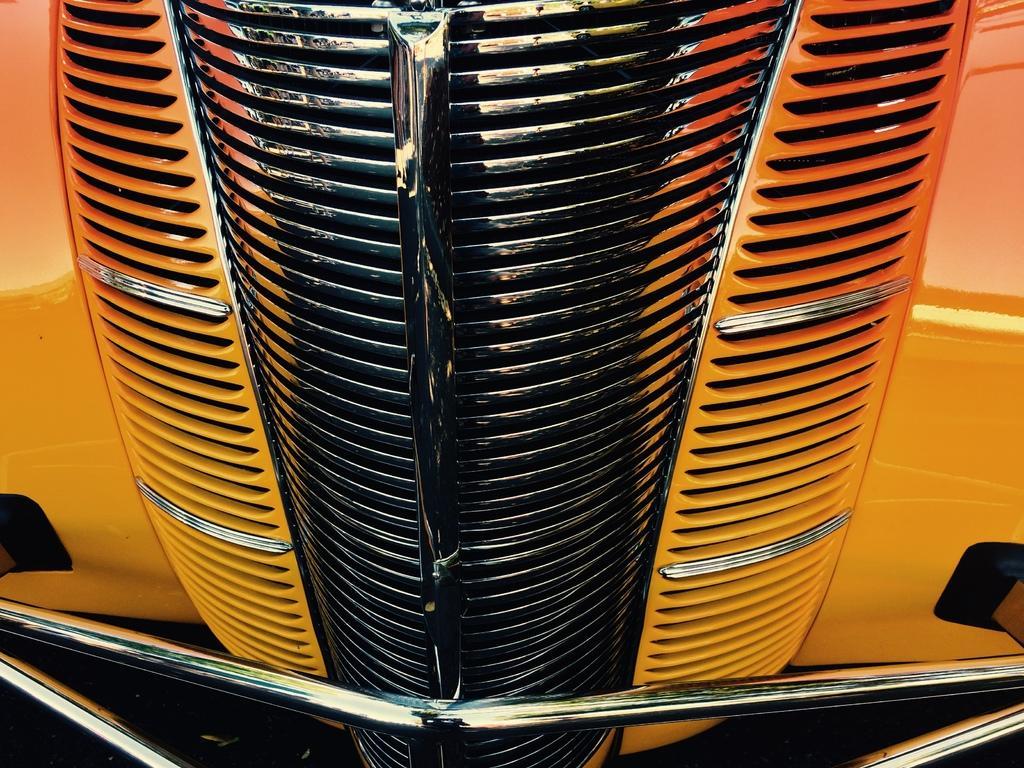Could you give a brief overview of what you see in this image? In this image there is a hood of a car. 